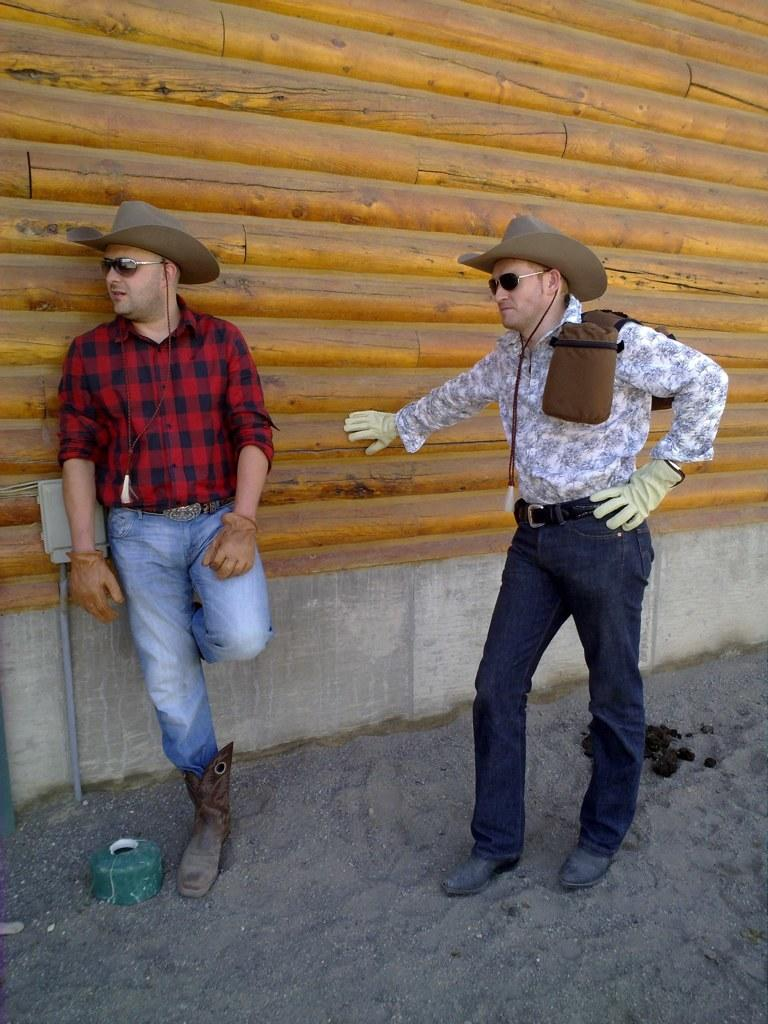How many people are in the image? There are two men in the image. What are the men wearing on their faces? The men are wearing goggles. What type of headwear are the men wearing? The men are wearing caps. Where are the men standing? The men are standing on the ground. What can be seen in the background of the image? There is a wall in the background of the image. What type of crack is visible on the wall in the image? There is no crack visible on the wall in the image. What type of branch can be seen in the room in the image? There is no room present in the image, and therefore no branch can be seen. 